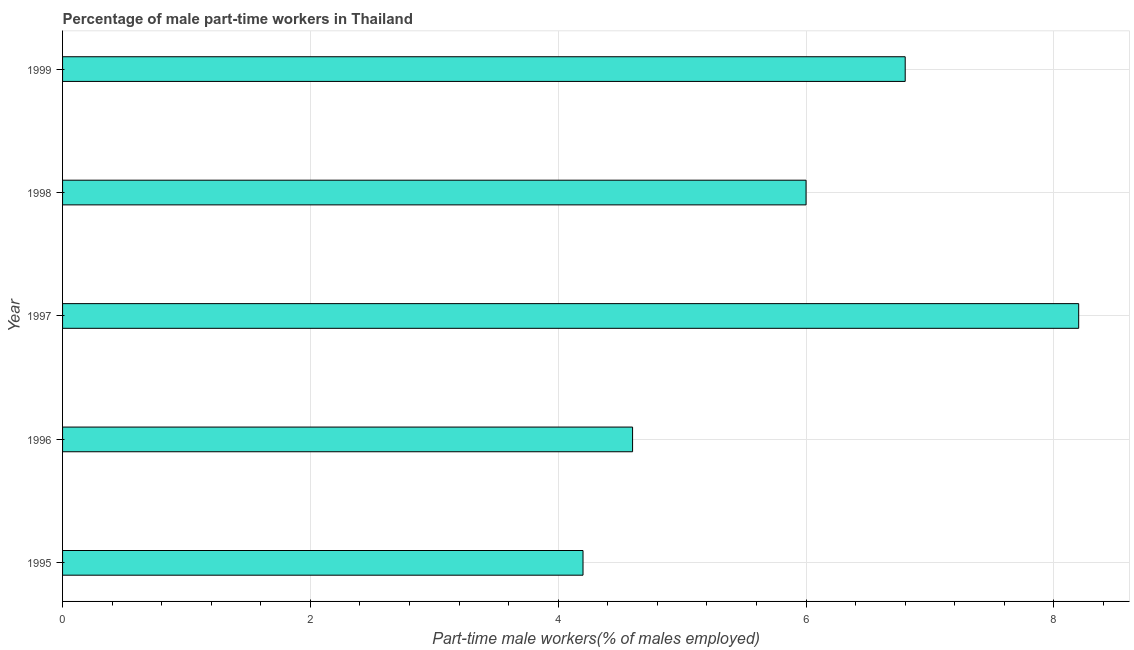Does the graph contain grids?
Provide a succinct answer. Yes. What is the title of the graph?
Keep it short and to the point. Percentage of male part-time workers in Thailand. What is the label or title of the X-axis?
Ensure brevity in your answer.  Part-time male workers(% of males employed). What is the label or title of the Y-axis?
Your answer should be very brief. Year. What is the percentage of part-time male workers in 1996?
Your answer should be very brief. 4.6. Across all years, what is the maximum percentage of part-time male workers?
Offer a terse response. 8.2. Across all years, what is the minimum percentage of part-time male workers?
Keep it short and to the point. 4.2. In which year was the percentage of part-time male workers maximum?
Provide a succinct answer. 1997. In which year was the percentage of part-time male workers minimum?
Provide a short and direct response. 1995. What is the sum of the percentage of part-time male workers?
Keep it short and to the point. 29.8. What is the difference between the percentage of part-time male workers in 1995 and 1996?
Give a very brief answer. -0.4. What is the average percentage of part-time male workers per year?
Offer a very short reply. 5.96. What is the ratio of the percentage of part-time male workers in 1995 to that in 1997?
Provide a short and direct response. 0.51. Is the percentage of part-time male workers in 1997 less than that in 1998?
Offer a terse response. No. What is the difference between the highest and the second highest percentage of part-time male workers?
Offer a very short reply. 1.4. What is the difference between the highest and the lowest percentage of part-time male workers?
Your answer should be very brief. 4. How many bars are there?
Provide a short and direct response. 5. Are all the bars in the graph horizontal?
Your answer should be very brief. Yes. How many years are there in the graph?
Offer a very short reply. 5. Are the values on the major ticks of X-axis written in scientific E-notation?
Keep it short and to the point. No. What is the Part-time male workers(% of males employed) of 1995?
Your response must be concise. 4.2. What is the Part-time male workers(% of males employed) in 1996?
Provide a succinct answer. 4.6. What is the Part-time male workers(% of males employed) of 1997?
Provide a succinct answer. 8.2. What is the Part-time male workers(% of males employed) in 1998?
Your answer should be very brief. 6. What is the Part-time male workers(% of males employed) of 1999?
Provide a short and direct response. 6.8. What is the difference between the Part-time male workers(% of males employed) in 1995 and 1996?
Offer a very short reply. -0.4. What is the difference between the Part-time male workers(% of males employed) in 1995 and 1997?
Keep it short and to the point. -4. What is the difference between the Part-time male workers(% of males employed) in 1995 and 1998?
Keep it short and to the point. -1.8. What is the difference between the Part-time male workers(% of males employed) in 1996 and 1999?
Your answer should be very brief. -2.2. What is the difference between the Part-time male workers(% of males employed) in 1997 and 1998?
Your answer should be compact. 2.2. What is the difference between the Part-time male workers(% of males employed) in 1998 and 1999?
Offer a very short reply. -0.8. What is the ratio of the Part-time male workers(% of males employed) in 1995 to that in 1997?
Offer a very short reply. 0.51. What is the ratio of the Part-time male workers(% of males employed) in 1995 to that in 1998?
Keep it short and to the point. 0.7. What is the ratio of the Part-time male workers(% of males employed) in 1995 to that in 1999?
Provide a succinct answer. 0.62. What is the ratio of the Part-time male workers(% of males employed) in 1996 to that in 1997?
Offer a terse response. 0.56. What is the ratio of the Part-time male workers(% of males employed) in 1996 to that in 1998?
Provide a short and direct response. 0.77. What is the ratio of the Part-time male workers(% of males employed) in 1996 to that in 1999?
Your answer should be very brief. 0.68. What is the ratio of the Part-time male workers(% of males employed) in 1997 to that in 1998?
Your answer should be very brief. 1.37. What is the ratio of the Part-time male workers(% of males employed) in 1997 to that in 1999?
Make the answer very short. 1.21. What is the ratio of the Part-time male workers(% of males employed) in 1998 to that in 1999?
Offer a terse response. 0.88. 